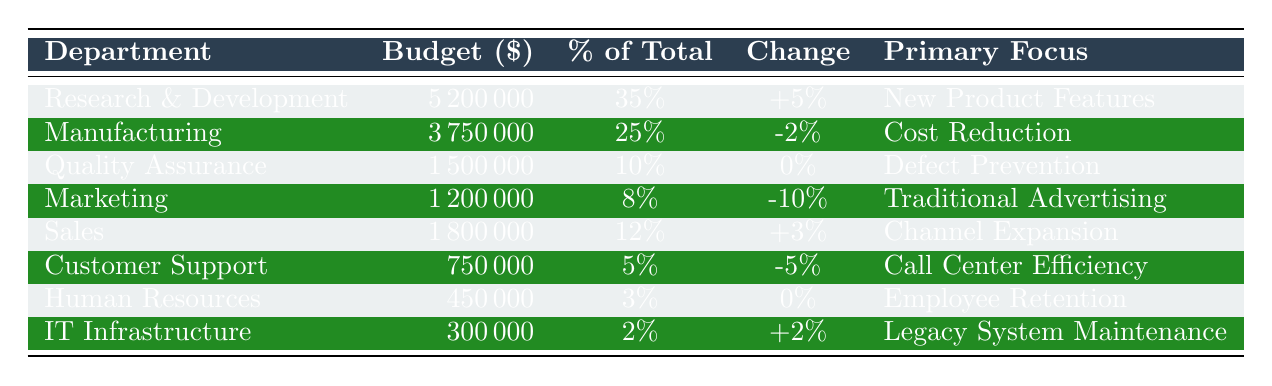What is the budget allocation for the Research & Development department? The budget allocation for the Research & Development department is directly listed in the table under the "Budget Allocation ($)" column. It shows a value of 5,200,000.
Answer: 5,200,000 What percentage of the total budget does the Marketing department receive? The percentage of the total budget allocated to the Marketing department can be found in the "Percentage of Total" column. It is recorded as 8%.
Answer: 8% Which department had the highest change in budget from 2022? Comparing the "Change from 2022" column, the Research & Development department shows the largest increase of +5%.
Answer: Research & Development What is the total budget allocation for all departments combined? To find the total budget allocation, sum all the budget values from the "Budget Allocation ($)" column: 5,200,000 + 3,750,000 + 1,500,000 + 1,200,000 + 1,800,000 + 750,000 + 450,000 + 300,000 = 14,950,000.
Answer: 14,950,000 Which department has no change in budget compared to 2022? The departments with a "Change from 2022" of 0% need to be identified by checking the respective column. Quality Assurance and Human Resources both show no change.
Answer: Quality Assurance, Human Resources Is the budget for Customer Support greater than the budget for Human Resources? Comparing the values in the "Budget Allocation ($)" column, Customer Support has 750,000 and Human Resources has 450,000. Since 750,000 is greater than 450,000, the statement is true.
Answer: Yes What is the average budget allocation among all departments? First, sum all budget allocations: 14,950,000. Then divide by the number of departments (8): 14,950,000 / 8 = 1,868,750.
Answer: 1,868,750 Which department focuses on employee retention and what is its percentage of the total budget? The Human Resources department focuses on employee retention, and its budget percentage is found in the "Percentage of Total" column, which indicates 3%.
Answer: 3% Did the Manufacturing department decrease its budget from the previous year? The "Change from 2022" entry for Manufacturing is recorded as -2%, which indicates a decrease in its budget allocation compared to 2022.
Answer: Yes What is the total budget allocated to departments focusing on traditional advertising and cost reduction? Identify departments focusing on these areas: Marketing (1,200,000) and Manufacturing (3,750,000). Adding these together gives: 1,200,000 + 3,750,000 = 4,950,000.
Answer: 4,950,000 